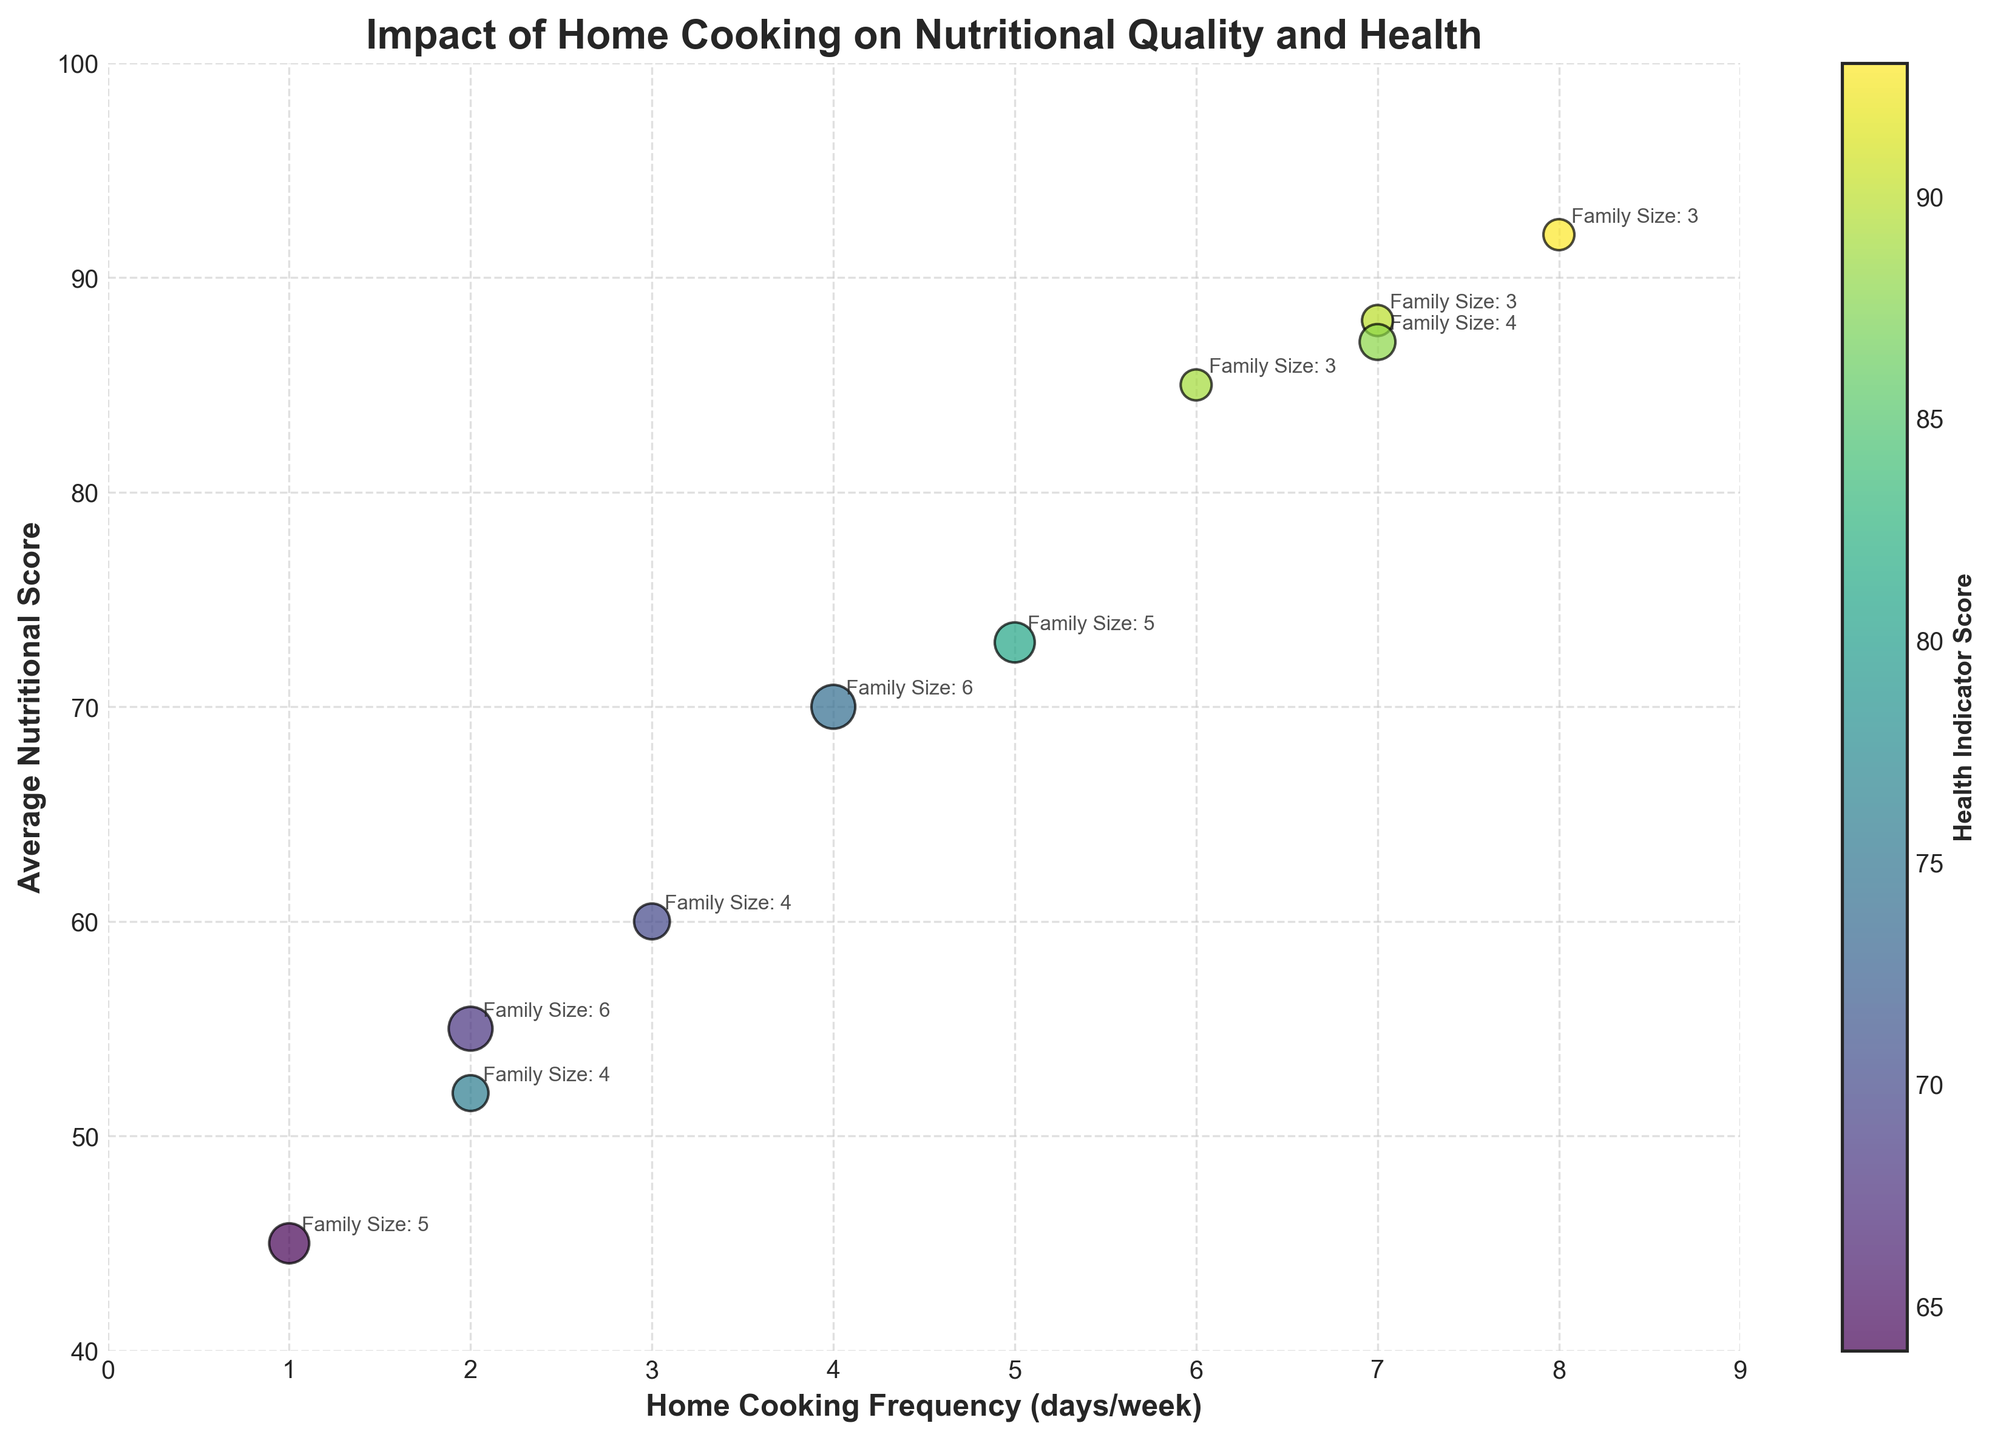How often do families with the highest nutritional scores cook at home? Families with the highest nutritional scores (around 88-92) cook at home 7-8 times a week, according to the chart.
Answer: 7-8 times a week What is the title of the figure? The title can be found at the top of the figure and reads: "Impact of Home Cooking on Nutritional Quality and Health."
Answer: Impact of Home Cooking on Nutritional Quality and Health How does the family size affect the bubble size in the chart? Larger bubbles correspond to larger family sizes. The bubble size is directly proportional to family size, as it’s calculated by multiplying the family size by 50.
Answer: Larger bubbles = larger family size Is there any family that cooks at home only once a week? If so, what is their average BMI? There is one family that cooks at home once a week, and their average BMI is visually identified on the y-axis.
Answer: 28.9 Which family has a higher health indicator score, one that cooks 2 times a week or one that cooks 7 times a week? Comparing the data points for families cooking 2 times a week and 7 times a week, the family that cooks 7 times a week has an average health indicator score of around 88-90, while the one that cooks 2 times a week has scores of around 68-76. Therefore, the family that cooks 7 times a week has a higher score.
Answer: The one that cooks 7 times a week What correlation can be observed between home cooking frequency and average nutritional score? Observing the x-axis (home cooking frequency) and the y-axis (average nutritional score), the trend shows that higher home cooking frequency tends to align with higher average nutritional scores.
Answer: Positive correlation If a family has an average nutritional score of 70, how frequently do they cook at home, and what is their family size? By locating the nutritional score of 70 on the y-axis, it identifies that the family cooks 4 times a week and has a family size of 6.
Answer: 4 times/week, Family Size: 6 What family size can be observed for the family with the highest home cooking frequency? For the family with a home cooking frequency of 8 days per week, the bubble indicates a family size of 3, as annotated on the chart.
Answer: 3 Between cooking 3 times a week and cooking 6 times a week, which frequency results in a better average health indicator score? By comparing the bubbles at 3 and 6 cooking frequencies on the x-axis, the family's health indicator score at 6 times a week (around 89) is higher than at 3 times a week (around 70).
Answer: 6 times a week Which family does not fit the general trend between home cooking frequency and health indicator score? Most families follow the trend of increased cooking frequency correlating with higher health indicator scores. However, a family cooking 4 times a week has a lower score of 74 compared to families cooking slightly more or less frequently, which might indicate an exception.
Answer: Family cooking 4 times a week (score of 74) 